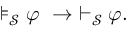Convert formula to latex. <formula><loc_0><loc_0><loc_500><loc_500>\models _ { \mathcal { S } } \varphi \ \to \ \vdash _ { \mathcal { S } } \varphi .</formula> 